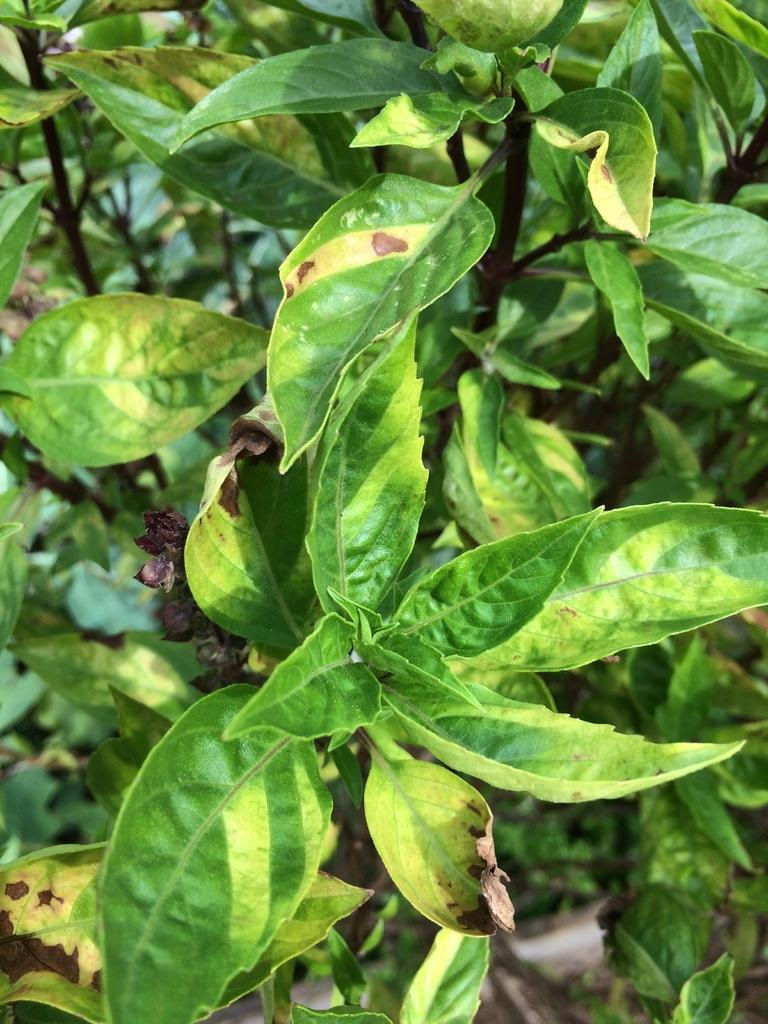What color are the leaves in the image? The leaves in the image are green. What type of pleasure can be seen in the image? There is no indication of pleasure in the image; it only features green color leaves. 